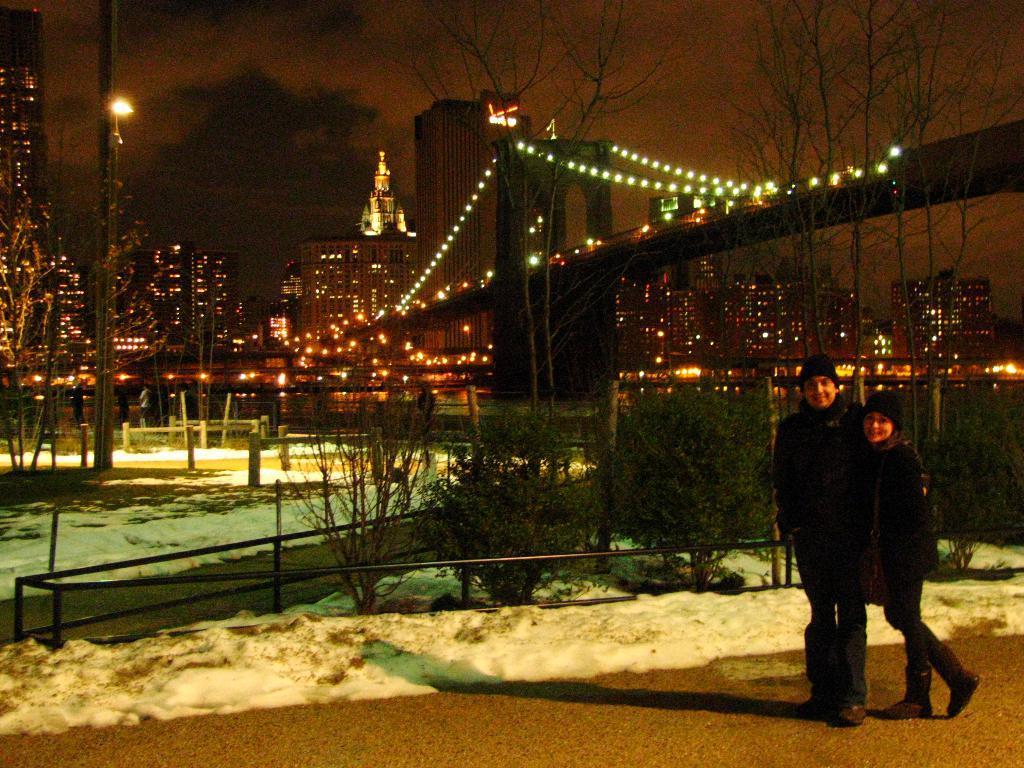Can you describe this image briefly? In this image we can see two persons. Behind the persons we can see a group of plants, buildings, lights and a bridge. On the left side, we can see a tree and a pole with lights. 